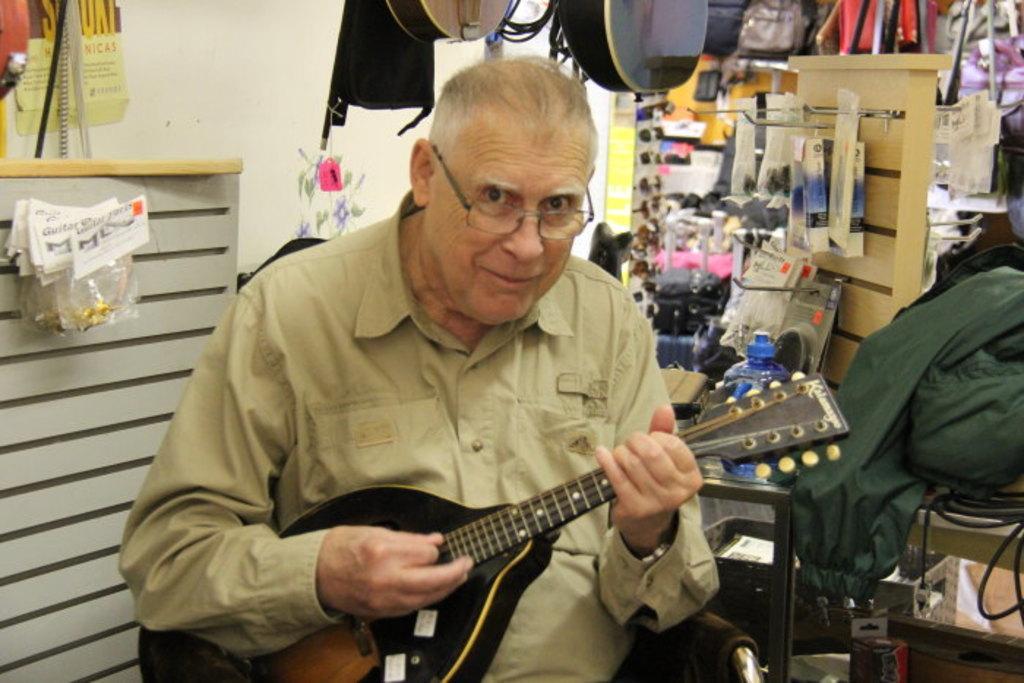Can you describe this image briefly? This is the picture of a man holding a music instrument. Behind the man there is a table and a wall. 